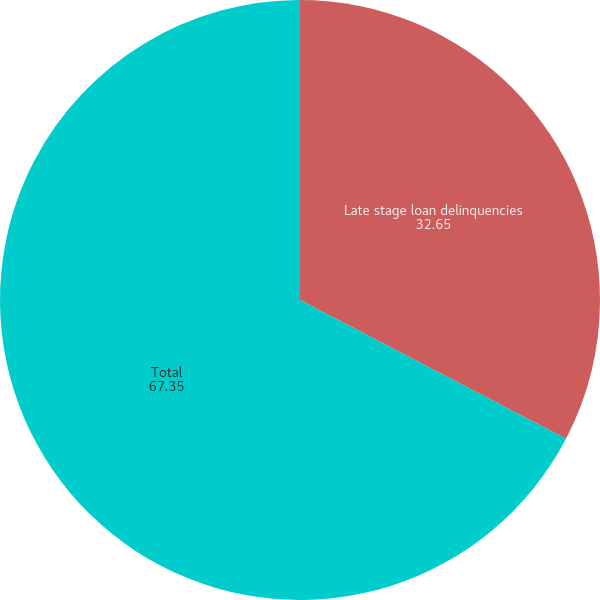Convert chart to OTSL. <chart><loc_0><loc_0><loc_500><loc_500><pie_chart><fcel>Late stage loan delinquencies<fcel>Total<nl><fcel>32.65%<fcel>67.35%<nl></chart> 